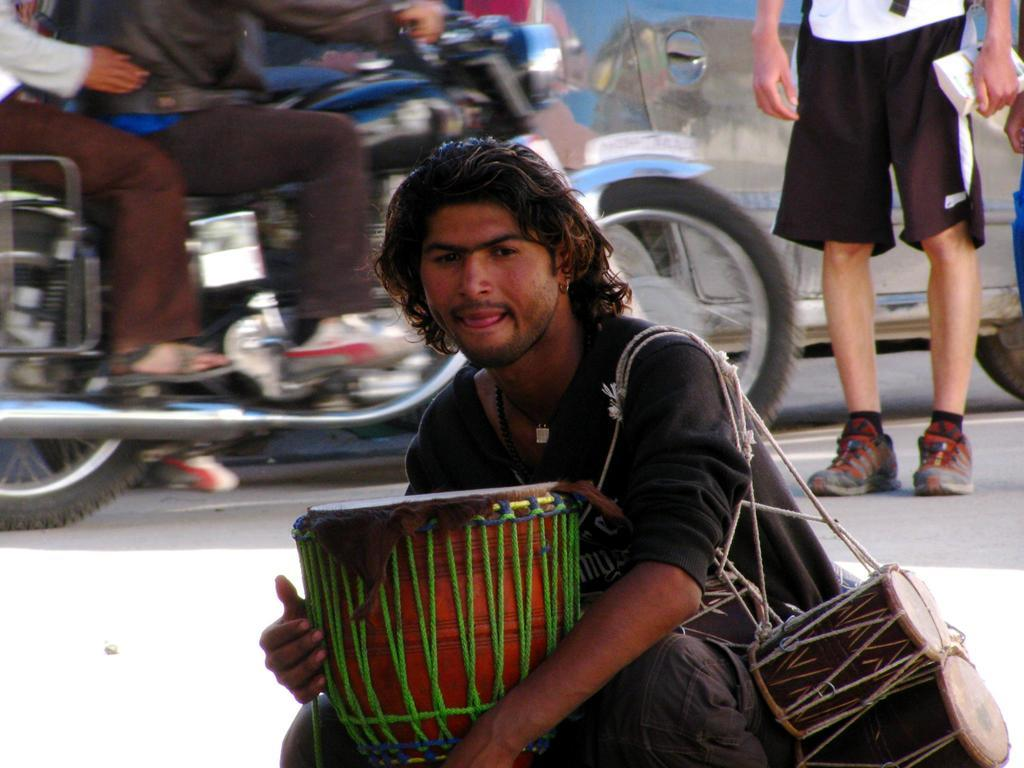What is the man in the foreground of the image doing? The man in the foreground of the image is sitting with musical instruments. What can be seen happening in the background of the image? There are two men riding a bike and a car visible in the background of the image. There is also a man standing alone in the background. How many people are involved in the activities in the background? There are three people involved in the activities in the background: two men riding a bike and one man standing alone. What type of pancake is the man eating while riding the bike in the image? There is no man eating a pancake in the image. The image shows two men riding a bike, but there is no mention of a pancake or any food. 